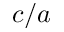Convert formula to latex. <formula><loc_0><loc_0><loc_500><loc_500>c / a</formula> 